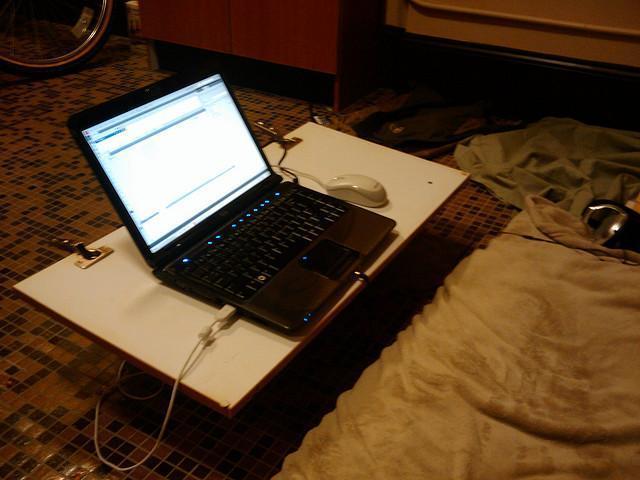Is the statement "The bicycle is beside the couch." accurate regarding the image?
Answer yes or no. No. 